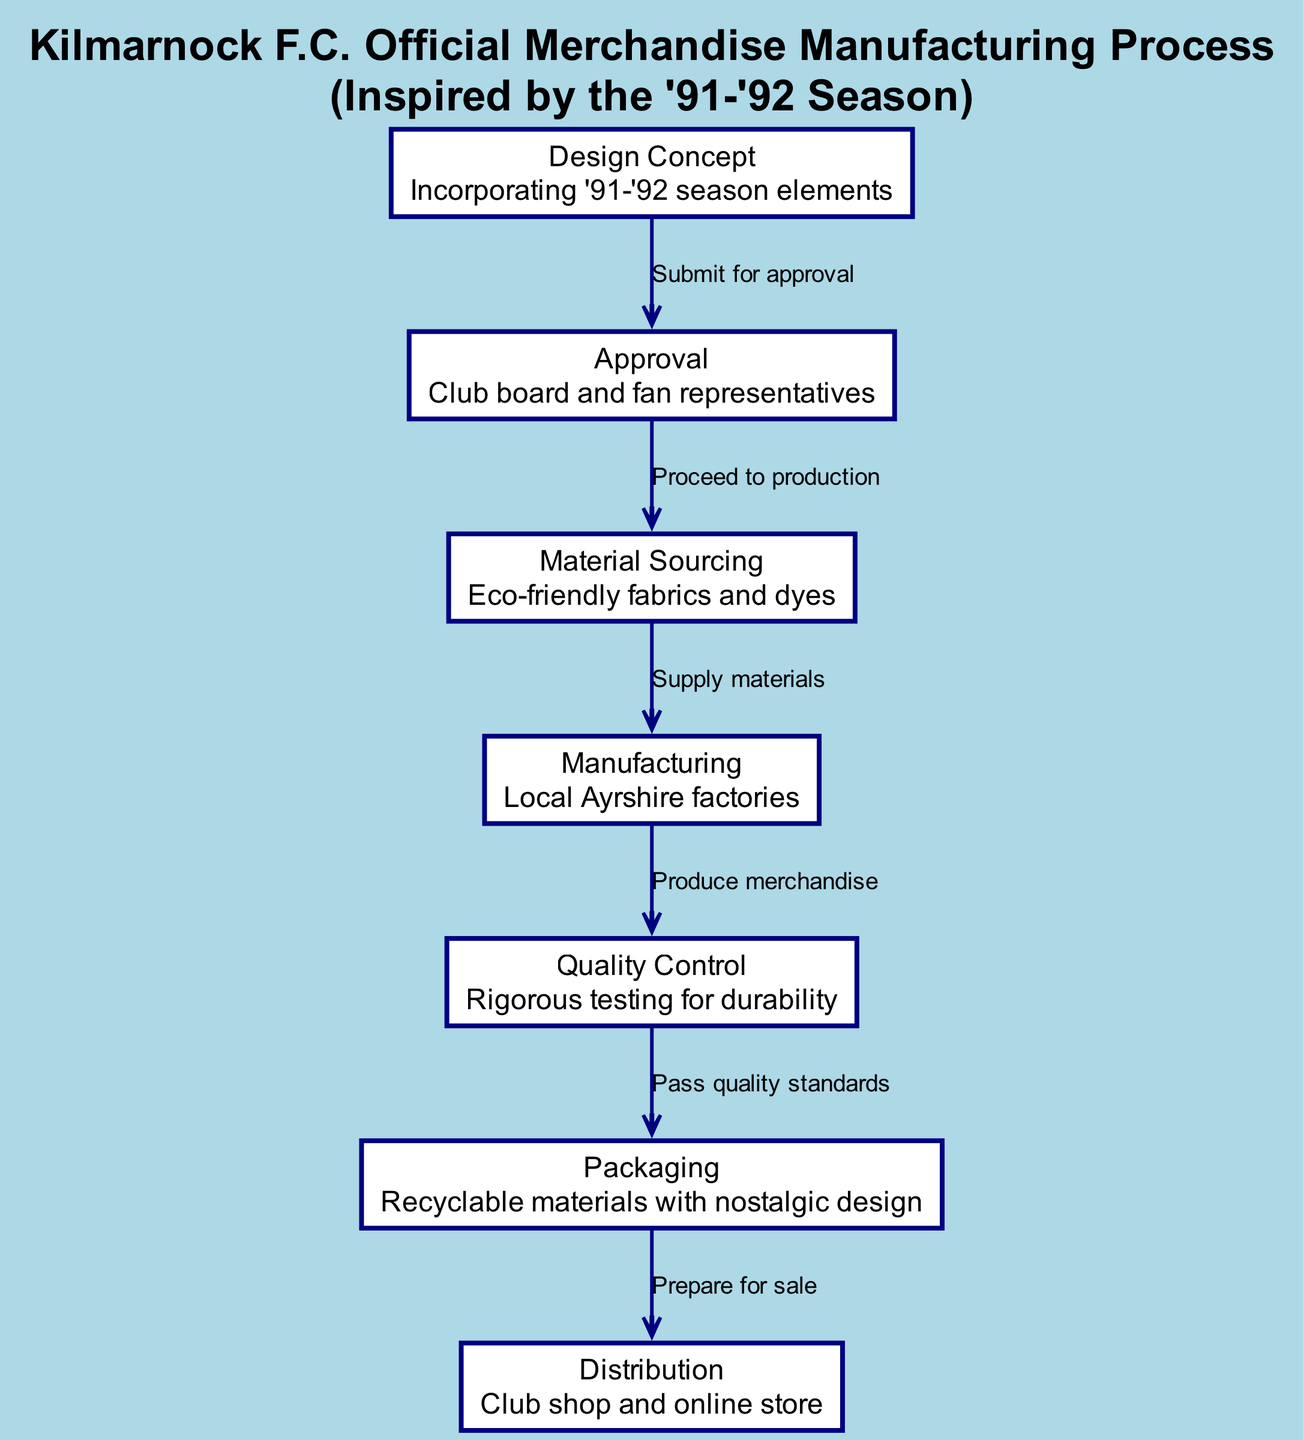What is the first step in the manufacturing process? The first step is labeled as "Design Concept," which incorporates elements from the '91-'92 season. This can be identified as it is the top node in the diagram and the starting point of the process flow.
Answer: Design Concept How many total nodes are present in the diagram? By counting each labeled section in the diagram, the total number of nodes is determined to be seven, as each stage from design to distribution counts as a separate node.
Answer: 7 What is the last step in the manufacturing process? The last step is labeled as "Distribution," which indicates the final phase of the merchandise process where the products are made available through the club shop and online store. This is identified as the last node reaching from packaging.
Answer: Distribution Which node follows "Approval" in the process? The node that immediately follows "Approval" is "Material Sourcing." This is evident from the directed edge leading from the Approval node to the Material Sourcing node.
Answer: Material Sourcing What type of materials are sourced in the "Material Sourcing" step? The "Material Sourcing" step describes sourcing "Eco-friendly fabrics and dyes." This information is presented in the node's description, which specifically highlights the type of materials used.
Answer: Eco-friendly fabrics and dyes What must occur after "Quality Control"? The step that must occur after "Quality Control" is "Packaging." This can be deduced by following the directed edge leading from the Quality Control node to the Packaging node in the process flow.
Answer: Packaging What is the significance of the arrow pointing from "Design Concept" to "Approval"? The arrow indicates the action "Submit for approval," which signifies that the design needs to be approved by the club board and fan representatives before proceeding to the next step. This flow of information establishes the process relationship between these two nodes.
Answer: Submit for approval Where is the emphasis on sustainability reflected in the diagram? The emphasis on sustainability is reflected in the "Material Sourcing" step, which specifically mentions the use of "Eco-friendly fabrics and dyes." This highlights the focus on sustainable practices within the merchandise manufacturing process.
Answer: Eco-friendly fabrics and dyes In what context is nostalgia mentioned in the diagram? Nostalgia is mentioned in the "Packaging" node, which specifies that recyclable materials will feature a nostalgic design. This reflects the connection to Kilmarnock F.C.'s history and fan sentiments, particularly from the '91-'92 season perspective.
Answer: Nostalgic design 